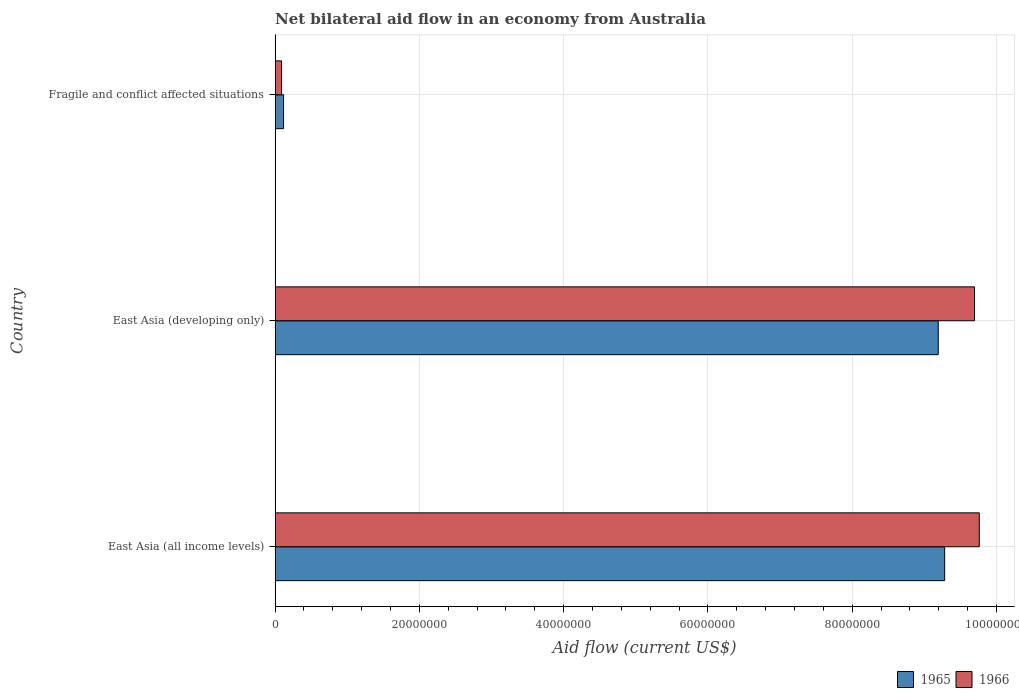How many different coloured bars are there?
Provide a short and direct response. 2. How many groups of bars are there?
Your response must be concise. 3. Are the number of bars per tick equal to the number of legend labels?
Provide a succinct answer. Yes. Are the number of bars on each tick of the Y-axis equal?
Your response must be concise. Yes. What is the label of the 1st group of bars from the top?
Provide a succinct answer. Fragile and conflict affected situations. In how many cases, is the number of bars for a given country not equal to the number of legend labels?
Provide a succinct answer. 0. What is the net bilateral aid flow in 1965 in East Asia (developing only)?
Give a very brief answer. 9.19e+07. Across all countries, what is the maximum net bilateral aid flow in 1966?
Your answer should be very brief. 9.76e+07. In which country was the net bilateral aid flow in 1966 maximum?
Your answer should be compact. East Asia (all income levels). In which country was the net bilateral aid flow in 1965 minimum?
Offer a terse response. Fragile and conflict affected situations. What is the total net bilateral aid flow in 1965 in the graph?
Give a very brief answer. 1.86e+08. What is the difference between the net bilateral aid flow in 1965 in East Asia (all income levels) and that in East Asia (developing only)?
Provide a short and direct response. 8.90e+05. What is the difference between the net bilateral aid flow in 1966 in East Asia (developing only) and the net bilateral aid flow in 1965 in Fragile and conflict affected situations?
Offer a terse response. 9.58e+07. What is the average net bilateral aid flow in 1966 per country?
Ensure brevity in your answer.  6.52e+07. What is the difference between the net bilateral aid flow in 1965 and net bilateral aid flow in 1966 in East Asia (developing only)?
Your response must be concise. -5.03e+06. What is the ratio of the net bilateral aid flow in 1965 in East Asia (developing only) to that in Fragile and conflict affected situations?
Make the answer very short. 77.9. What is the difference between the highest and the second highest net bilateral aid flow in 1966?
Your answer should be very brief. 6.60e+05. What is the difference between the highest and the lowest net bilateral aid flow in 1965?
Your response must be concise. 9.16e+07. What does the 1st bar from the top in East Asia (developing only) represents?
Ensure brevity in your answer.  1966. What does the 2nd bar from the bottom in East Asia (developing only) represents?
Offer a very short reply. 1966. How many countries are there in the graph?
Your response must be concise. 3. What is the difference between two consecutive major ticks on the X-axis?
Your answer should be compact. 2.00e+07. Are the values on the major ticks of X-axis written in scientific E-notation?
Your answer should be compact. No. Where does the legend appear in the graph?
Make the answer very short. Bottom right. How many legend labels are there?
Provide a succinct answer. 2. How are the legend labels stacked?
Provide a succinct answer. Horizontal. What is the title of the graph?
Give a very brief answer. Net bilateral aid flow in an economy from Australia. Does "1962" appear as one of the legend labels in the graph?
Give a very brief answer. No. What is the label or title of the Y-axis?
Offer a very short reply. Country. What is the Aid flow (current US$) in 1965 in East Asia (all income levels)?
Your response must be concise. 9.28e+07. What is the Aid flow (current US$) of 1966 in East Asia (all income levels)?
Keep it short and to the point. 9.76e+07. What is the Aid flow (current US$) of 1965 in East Asia (developing only)?
Provide a succinct answer. 9.19e+07. What is the Aid flow (current US$) of 1966 in East Asia (developing only)?
Make the answer very short. 9.70e+07. What is the Aid flow (current US$) in 1965 in Fragile and conflict affected situations?
Give a very brief answer. 1.18e+06. Across all countries, what is the maximum Aid flow (current US$) in 1965?
Your answer should be very brief. 9.28e+07. Across all countries, what is the maximum Aid flow (current US$) of 1966?
Provide a short and direct response. 9.76e+07. Across all countries, what is the minimum Aid flow (current US$) in 1965?
Offer a terse response. 1.18e+06. What is the total Aid flow (current US$) in 1965 in the graph?
Ensure brevity in your answer.  1.86e+08. What is the total Aid flow (current US$) of 1966 in the graph?
Offer a terse response. 1.95e+08. What is the difference between the Aid flow (current US$) in 1965 in East Asia (all income levels) and that in East Asia (developing only)?
Offer a very short reply. 8.90e+05. What is the difference between the Aid flow (current US$) of 1966 in East Asia (all income levels) and that in East Asia (developing only)?
Provide a short and direct response. 6.60e+05. What is the difference between the Aid flow (current US$) of 1965 in East Asia (all income levels) and that in Fragile and conflict affected situations?
Your answer should be very brief. 9.16e+07. What is the difference between the Aid flow (current US$) of 1966 in East Asia (all income levels) and that in Fragile and conflict affected situations?
Your answer should be compact. 9.67e+07. What is the difference between the Aid flow (current US$) of 1965 in East Asia (developing only) and that in Fragile and conflict affected situations?
Give a very brief answer. 9.07e+07. What is the difference between the Aid flow (current US$) in 1966 in East Asia (developing only) and that in Fragile and conflict affected situations?
Provide a succinct answer. 9.60e+07. What is the difference between the Aid flow (current US$) in 1965 in East Asia (all income levels) and the Aid flow (current US$) in 1966 in East Asia (developing only)?
Your answer should be very brief. -4.14e+06. What is the difference between the Aid flow (current US$) of 1965 in East Asia (all income levels) and the Aid flow (current US$) of 1966 in Fragile and conflict affected situations?
Provide a succinct answer. 9.19e+07. What is the difference between the Aid flow (current US$) in 1965 in East Asia (developing only) and the Aid flow (current US$) in 1966 in Fragile and conflict affected situations?
Ensure brevity in your answer.  9.10e+07. What is the average Aid flow (current US$) in 1965 per country?
Ensure brevity in your answer.  6.20e+07. What is the average Aid flow (current US$) in 1966 per country?
Offer a very short reply. 6.52e+07. What is the difference between the Aid flow (current US$) in 1965 and Aid flow (current US$) in 1966 in East Asia (all income levels)?
Your answer should be compact. -4.80e+06. What is the difference between the Aid flow (current US$) in 1965 and Aid flow (current US$) in 1966 in East Asia (developing only)?
Your answer should be very brief. -5.03e+06. What is the difference between the Aid flow (current US$) in 1965 and Aid flow (current US$) in 1966 in Fragile and conflict affected situations?
Your answer should be compact. 2.80e+05. What is the ratio of the Aid flow (current US$) in 1965 in East Asia (all income levels) to that in East Asia (developing only)?
Provide a succinct answer. 1.01. What is the ratio of the Aid flow (current US$) in 1966 in East Asia (all income levels) to that in East Asia (developing only)?
Your answer should be compact. 1.01. What is the ratio of the Aid flow (current US$) of 1965 in East Asia (all income levels) to that in Fragile and conflict affected situations?
Offer a terse response. 78.65. What is the ratio of the Aid flow (current US$) of 1966 in East Asia (all income levels) to that in Fragile and conflict affected situations?
Offer a very short reply. 108.46. What is the ratio of the Aid flow (current US$) in 1965 in East Asia (developing only) to that in Fragile and conflict affected situations?
Make the answer very short. 77.9. What is the ratio of the Aid flow (current US$) of 1966 in East Asia (developing only) to that in Fragile and conflict affected situations?
Provide a short and direct response. 107.72. What is the difference between the highest and the second highest Aid flow (current US$) in 1965?
Offer a terse response. 8.90e+05. What is the difference between the highest and the second highest Aid flow (current US$) of 1966?
Offer a very short reply. 6.60e+05. What is the difference between the highest and the lowest Aid flow (current US$) in 1965?
Offer a terse response. 9.16e+07. What is the difference between the highest and the lowest Aid flow (current US$) of 1966?
Keep it short and to the point. 9.67e+07. 